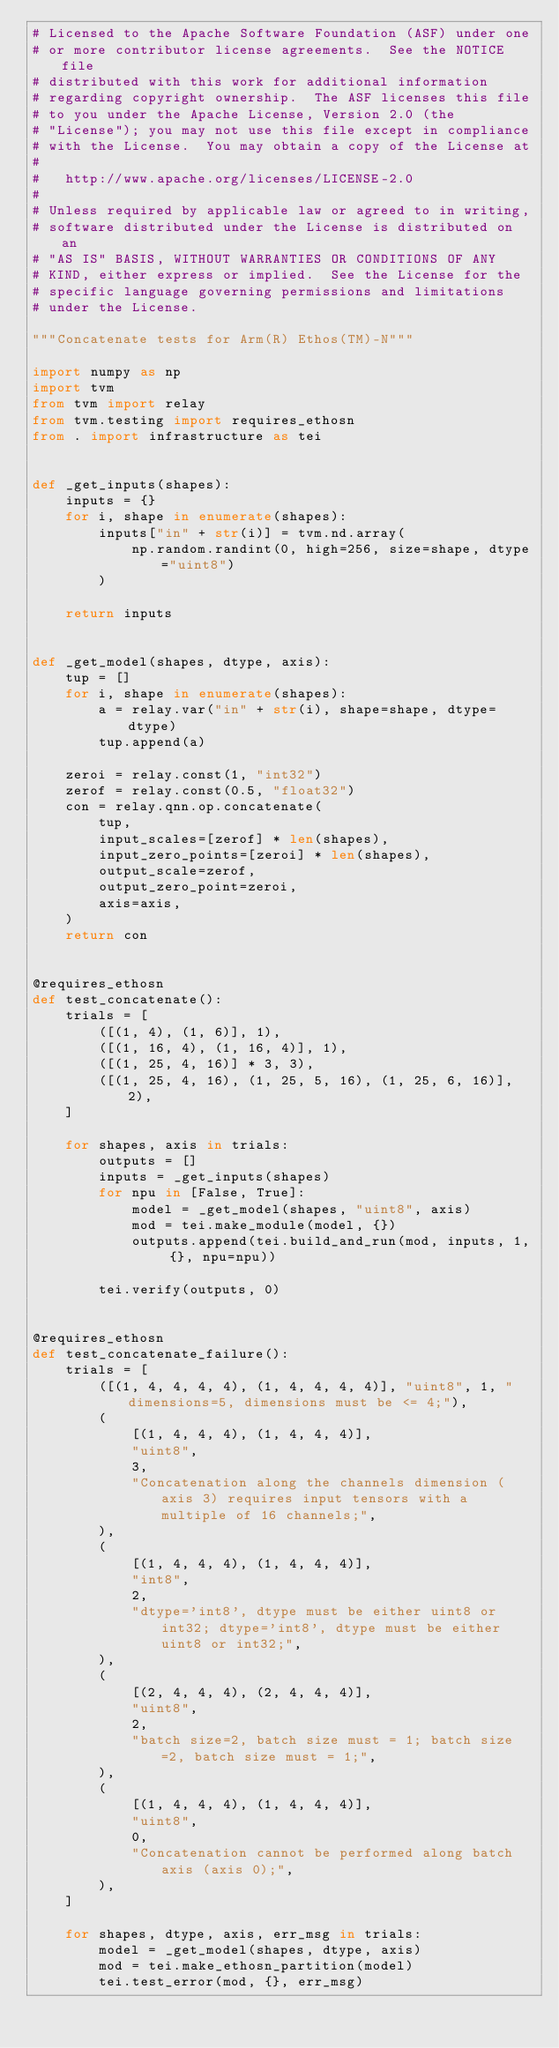Convert code to text. <code><loc_0><loc_0><loc_500><loc_500><_Python_># Licensed to the Apache Software Foundation (ASF) under one
# or more contributor license agreements.  See the NOTICE file
# distributed with this work for additional information
# regarding copyright ownership.  The ASF licenses this file
# to you under the Apache License, Version 2.0 (the
# "License"); you may not use this file except in compliance
# with the License.  You may obtain a copy of the License at
#
#   http://www.apache.org/licenses/LICENSE-2.0
#
# Unless required by applicable law or agreed to in writing,
# software distributed under the License is distributed on an
# "AS IS" BASIS, WITHOUT WARRANTIES OR CONDITIONS OF ANY
# KIND, either express or implied.  See the License for the
# specific language governing permissions and limitations
# under the License.

"""Concatenate tests for Arm(R) Ethos(TM)-N"""

import numpy as np
import tvm
from tvm import relay
from tvm.testing import requires_ethosn
from . import infrastructure as tei


def _get_inputs(shapes):
    inputs = {}
    for i, shape in enumerate(shapes):
        inputs["in" + str(i)] = tvm.nd.array(
            np.random.randint(0, high=256, size=shape, dtype="uint8")
        )

    return inputs


def _get_model(shapes, dtype, axis):
    tup = []
    for i, shape in enumerate(shapes):
        a = relay.var("in" + str(i), shape=shape, dtype=dtype)
        tup.append(a)

    zeroi = relay.const(1, "int32")
    zerof = relay.const(0.5, "float32")
    con = relay.qnn.op.concatenate(
        tup,
        input_scales=[zerof] * len(shapes),
        input_zero_points=[zeroi] * len(shapes),
        output_scale=zerof,
        output_zero_point=zeroi,
        axis=axis,
    )
    return con


@requires_ethosn
def test_concatenate():
    trials = [
        ([(1, 4), (1, 6)], 1),
        ([(1, 16, 4), (1, 16, 4)], 1),
        ([(1, 25, 4, 16)] * 3, 3),
        ([(1, 25, 4, 16), (1, 25, 5, 16), (1, 25, 6, 16)], 2),
    ]

    for shapes, axis in trials:
        outputs = []
        inputs = _get_inputs(shapes)
        for npu in [False, True]:
            model = _get_model(shapes, "uint8", axis)
            mod = tei.make_module(model, {})
            outputs.append(tei.build_and_run(mod, inputs, 1, {}, npu=npu))

        tei.verify(outputs, 0)


@requires_ethosn
def test_concatenate_failure():
    trials = [
        ([(1, 4, 4, 4, 4), (1, 4, 4, 4, 4)], "uint8", 1, "dimensions=5, dimensions must be <= 4;"),
        (
            [(1, 4, 4, 4), (1, 4, 4, 4)],
            "uint8",
            3,
            "Concatenation along the channels dimension (axis 3) requires input tensors with a multiple of 16 channels;",
        ),
        (
            [(1, 4, 4, 4), (1, 4, 4, 4)],
            "int8",
            2,
            "dtype='int8', dtype must be either uint8 or int32; dtype='int8', dtype must be either uint8 or int32;",
        ),
        (
            [(2, 4, 4, 4), (2, 4, 4, 4)],
            "uint8",
            2,
            "batch size=2, batch size must = 1; batch size=2, batch size must = 1;",
        ),
        (
            [(1, 4, 4, 4), (1, 4, 4, 4)],
            "uint8",
            0,
            "Concatenation cannot be performed along batch axis (axis 0);",
        ),
    ]

    for shapes, dtype, axis, err_msg in trials:
        model = _get_model(shapes, dtype, axis)
        mod = tei.make_ethosn_partition(model)
        tei.test_error(mod, {}, err_msg)
</code> 